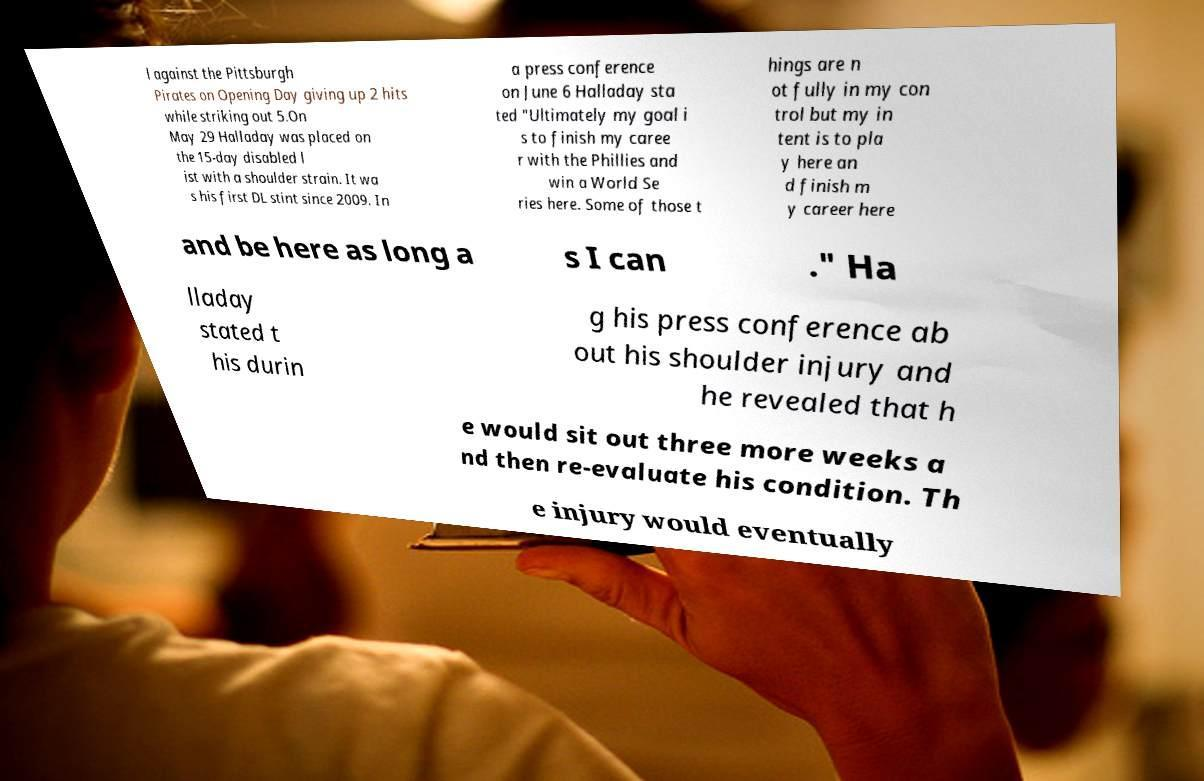Please read and relay the text visible in this image. What does it say? l against the Pittsburgh Pirates on Opening Day giving up 2 hits while striking out 5.On May 29 Halladay was placed on the 15-day disabled l ist with a shoulder strain. It wa s his first DL stint since 2009. In a press conference on June 6 Halladay sta ted "Ultimately my goal i s to finish my caree r with the Phillies and win a World Se ries here. Some of those t hings are n ot fully in my con trol but my in tent is to pla y here an d finish m y career here and be here as long a s I can ." Ha lladay stated t his durin g his press conference ab out his shoulder injury and he revealed that h e would sit out three more weeks a nd then re-evaluate his condition. Th e injury would eventually 